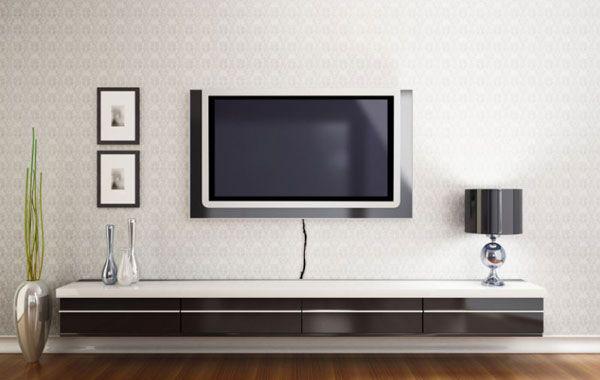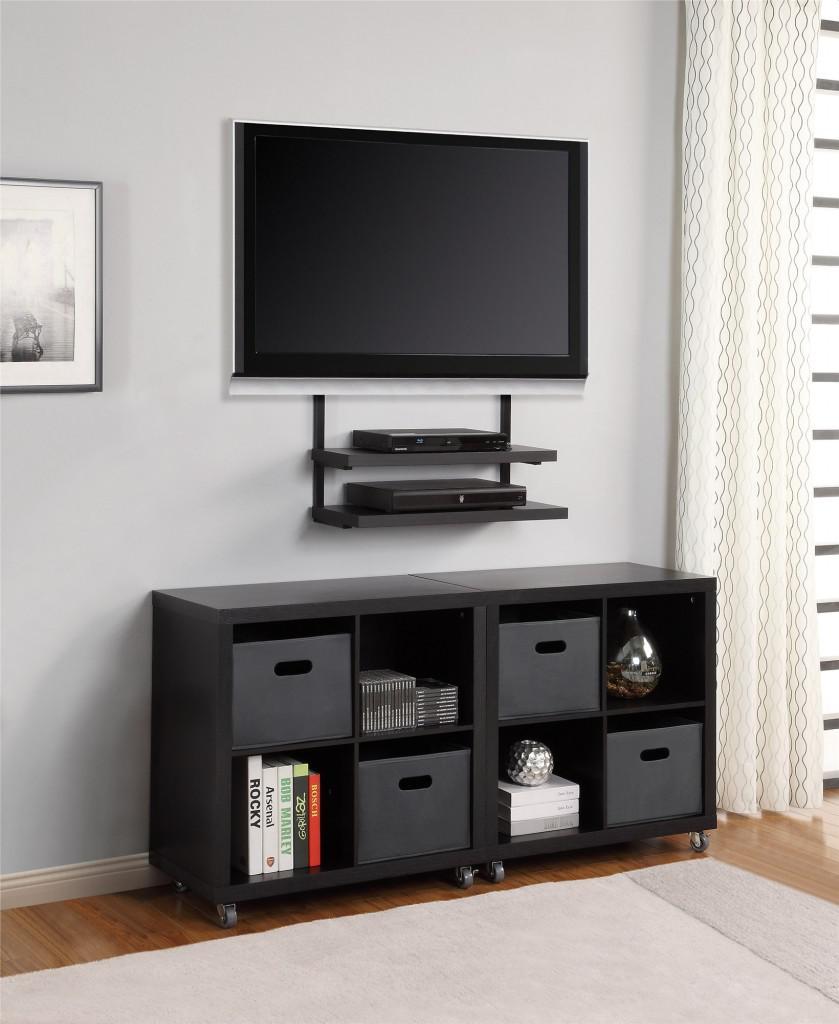The first image is the image on the left, the second image is the image on the right. For the images displayed, is the sentence "At least one image shows some type of green plant near a flat-screen TV, and exactly one image contains a TV with a picture on its screen." factually correct? Answer yes or no. No. The first image is the image on the left, the second image is the image on the right. Given the left and right images, does the statement "One of the images shows a TV that is not mounted to the wall." hold true? Answer yes or no. No. 